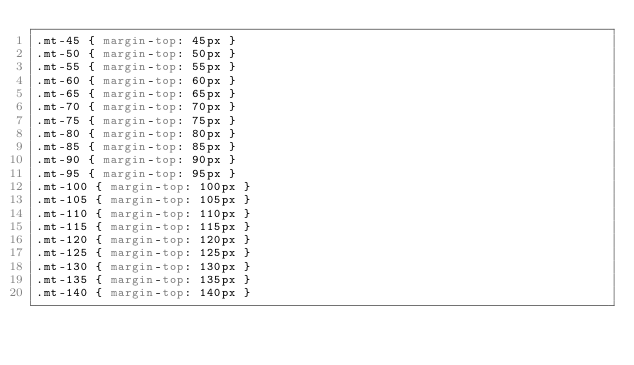<code> <loc_0><loc_0><loc_500><loc_500><_CSS_>.mt-45 { margin-top: 45px }
.mt-50 { margin-top: 50px }
.mt-55 { margin-top: 55px }
.mt-60 { margin-top: 60px }
.mt-65 { margin-top: 65px }
.mt-70 { margin-top: 70px }
.mt-75 { margin-top: 75px }
.mt-80 { margin-top: 80px }
.mt-85 { margin-top: 85px }
.mt-90 { margin-top: 90px }
.mt-95 { margin-top: 95px }
.mt-100 { margin-top: 100px }
.mt-105 { margin-top: 105px }
.mt-110 { margin-top: 110px }
.mt-115 { margin-top: 115px }
.mt-120 { margin-top: 120px }
.mt-125 { margin-top: 125px }
.mt-130 { margin-top: 130px }
.mt-135 { margin-top: 135px }
.mt-140 { margin-top: 140px }</code> 